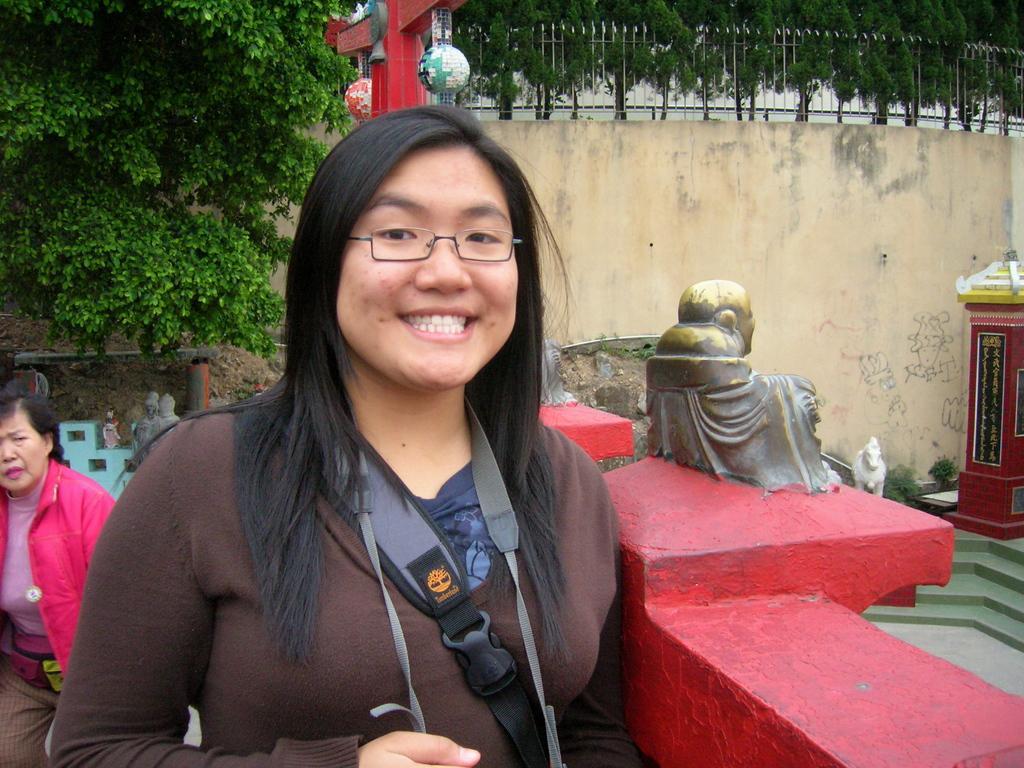Could you give a brief overview of what you see in this image? In the middle of the image a woman is standing and smiling. Beside her there is wall. Behind her a woman is standing and watching. Behind them there is a tree. Behind the tree there is wall. Behind the wall there are some trees. 